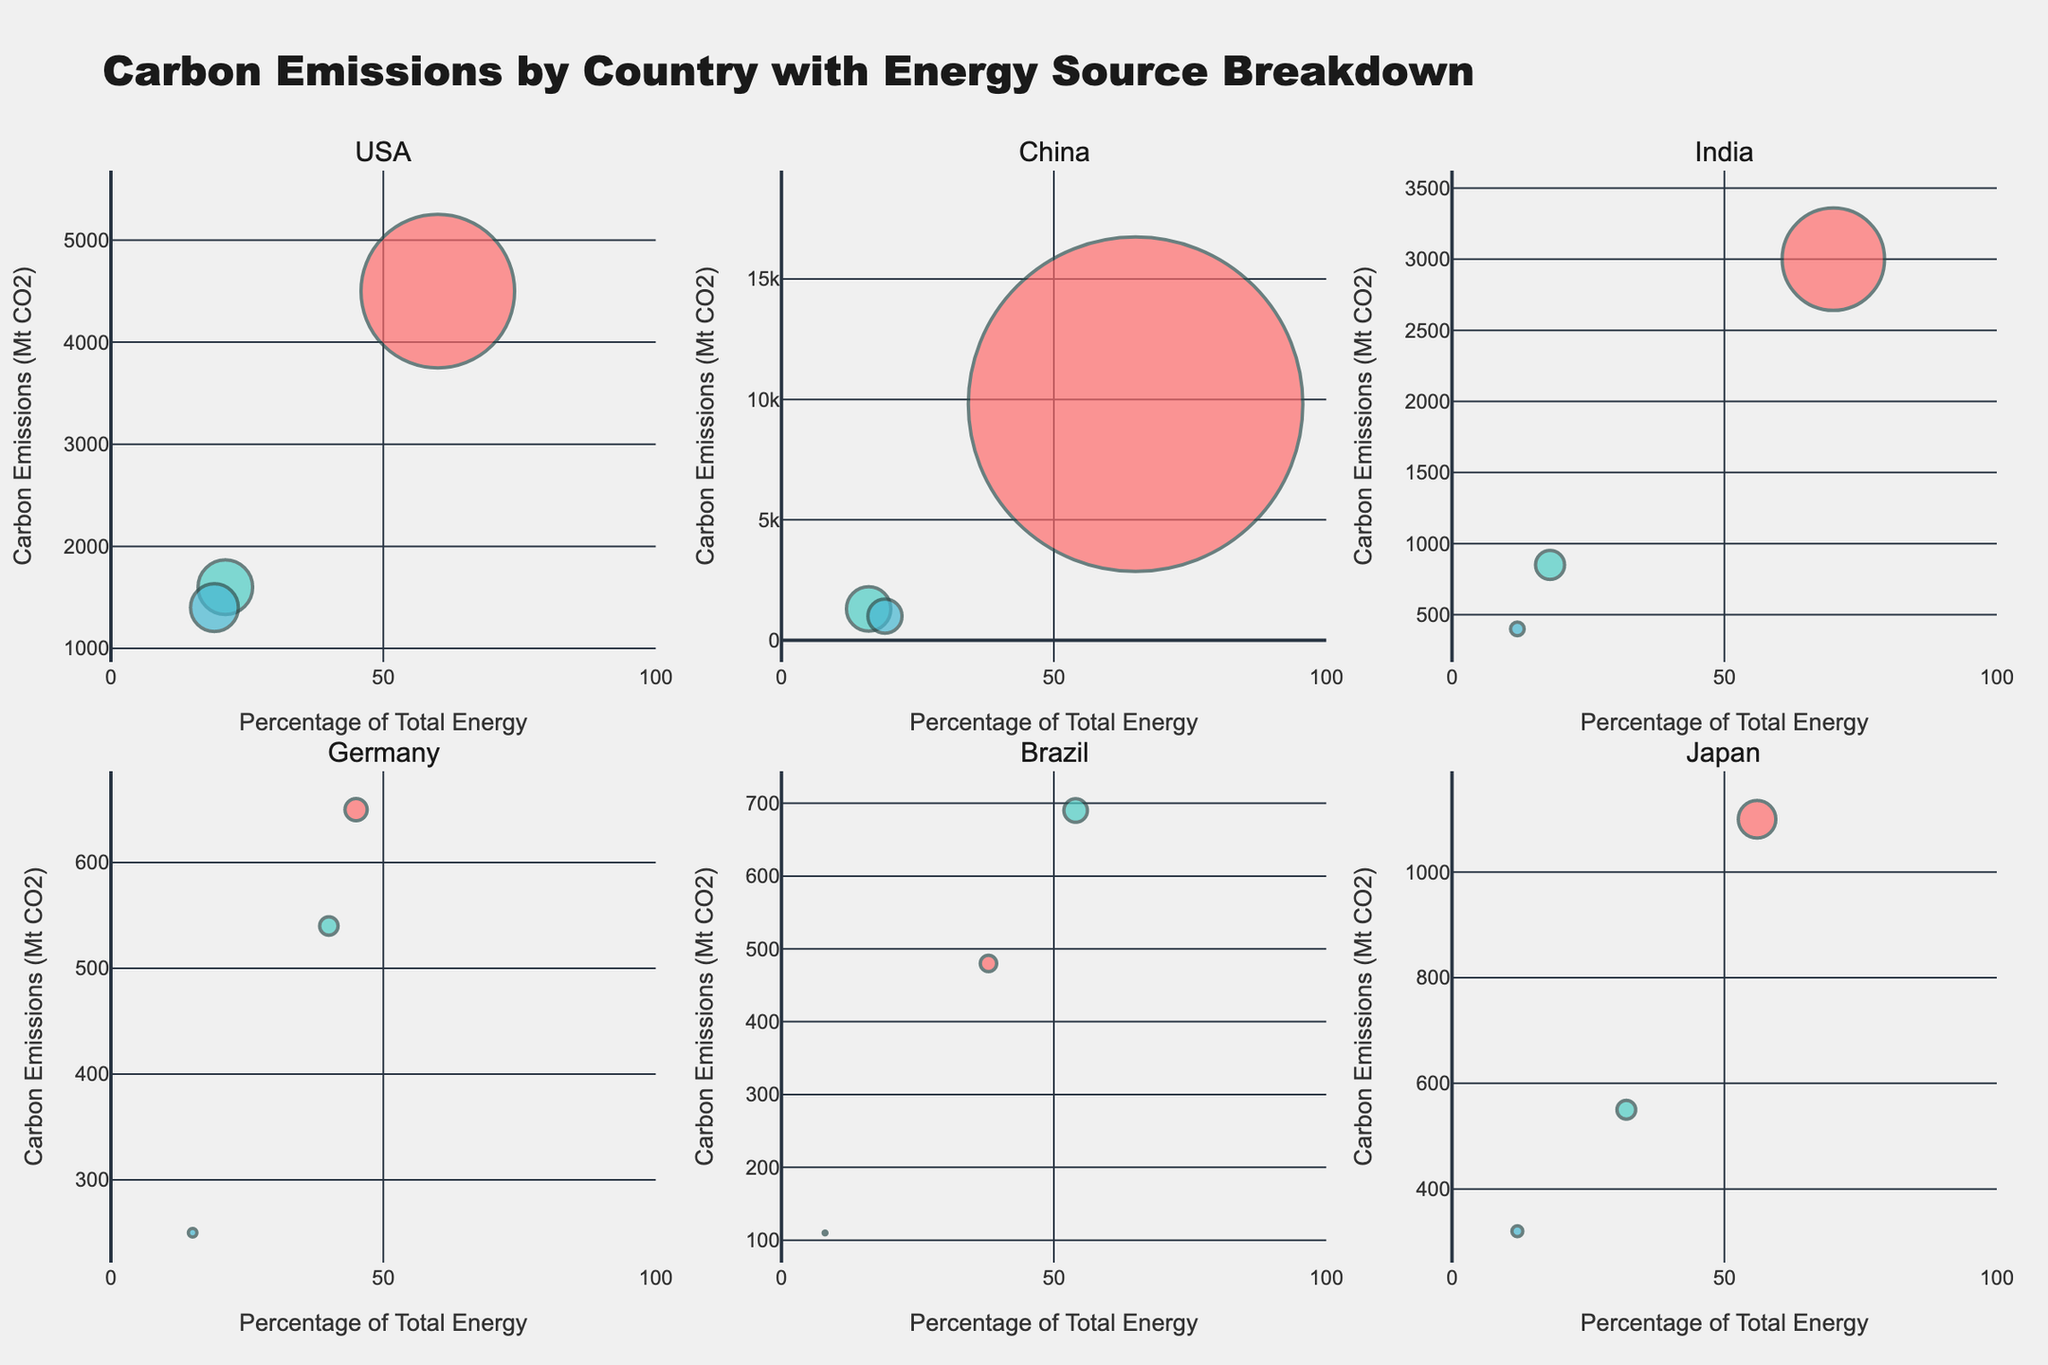What is the title of the figure? The title of the figure is typically displayed at the top of the chart. In this case, it reads "Carbon Emissions by Country with Energy Source Breakdown." This title is meant to give an overview of what the entire figure represents.
Answer: Carbon Emissions by Country with Energy Source Breakdown Which country is represented in the first subplot (top left)? The subplot titles provide this information. The first subplot in the top left corner is allocated to the USA.
Answer: USA How many countries have more than 1000 Mt CO2 carbon emissions from fossil fuels? To answer this, we count the countries where the bubble representing fossil fuels exceeds 1000 Mt CO2. From the chart, USA (4500), China (9800), and India (3000) meet this criterion.
Answer: 3 Which country has the highest percentage of renewable energy? By examining the x-axis labeled 'Percentage of Total Energy' and finding the highest value for renewables in each subplot, Brazil has the highest percentage at 54%.
Answer: Brazil What is the carbon emission from nuclear energy in India? Look at India's subplot, find the bubble for nuclear energy (text label "Nuclear"), and read its y-axis value, which shows 400 Mt CO2.
Answer: 400 Mt CO2 Compare the carbon emissions from fossil fuels in the USA and China. Which country emits more? Locate the bubbles for fossil fuels in the USA and China subplots, then compare their y-axis values. USA emits 4500 Mt CO2, while China emits 9800 Mt CO2, making China's emissions higher.
Answer: China Which country has the smallest bubble for fossil fuels, and what is the emission value? By visually inspecting all subplots and locating the smallest bubble for fossil fuels, Germany has the smallest bubble with 650 Mt CO2 emissions.
Answer: Germany, 650 Mt CO2 What is the combined carbon emission from nuclear energy in Germany and Japan? Locate the nuclear energy emission values for Germany and Japan (250 Mt CO2 and 320 Mt CO2 respectively), then sum them up: 250 + 320 = 570 Mt CO2.
Answer: 570 Mt CO2 What is the range of carbon emissions (minimum to maximum) for renewables across all countries? By examining all renewable energy bubbles and noting their y-axis values, the lowest is 540 Mt CO2 (Germany) and the highest is 1600 Mt CO2 (USA). Therefore, the range is 540 - 1600 Mt CO2.
Answer: 540 - 1600 Mt CO2 What percentage of total energy does fossil fuels account for in India? Find India’s subplot, locate the bubble for fossil fuels, and note its x-axis value, which is 70%.
Answer: 70% 